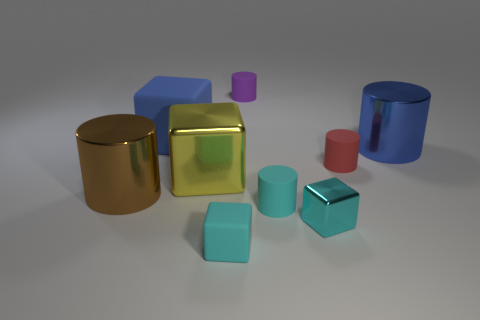Subtract all large blue shiny cylinders. How many cylinders are left? 4 Subtract all cylinders. How many objects are left? 4 Subtract 4 cubes. How many cubes are left? 0 Subtract all yellow cubes. Subtract all gray balls. How many cubes are left? 3 Subtract all purple balls. How many yellow cubes are left? 1 Subtract all tiny matte cylinders. Subtract all yellow metallic cubes. How many objects are left? 5 Add 7 yellow metal things. How many yellow metal things are left? 8 Add 7 big yellow shiny objects. How many big yellow shiny objects exist? 8 Subtract all red cylinders. How many cylinders are left? 4 Subtract 1 red cylinders. How many objects are left? 8 